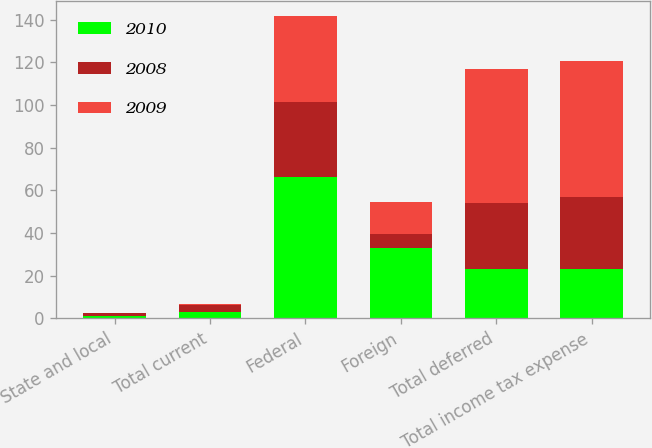Convert chart to OTSL. <chart><loc_0><loc_0><loc_500><loc_500><stacked_bar_chart><ecel><fcel>State and local<fcel>Total current<fcel>Federal<fcel>Foreign<fcel>Total deferred<fcel>Total income tax expense<nl><fcel>2010<fcel>1<fcel>3<fcel>66.4<fcel>33.1<fcel>22.95<fcel>22.95<nl><fcel>2008<fcel>1.3<fcel>3.2<fcel>35.2<fcel>6.4<fcel>30.9<fcel>34.1<nl><fcel>2009<fcel>0.2<fcel>0.7<fcel>40.3<fcel>15<fcel>63.1<fcel>63.8<nl></chart> 